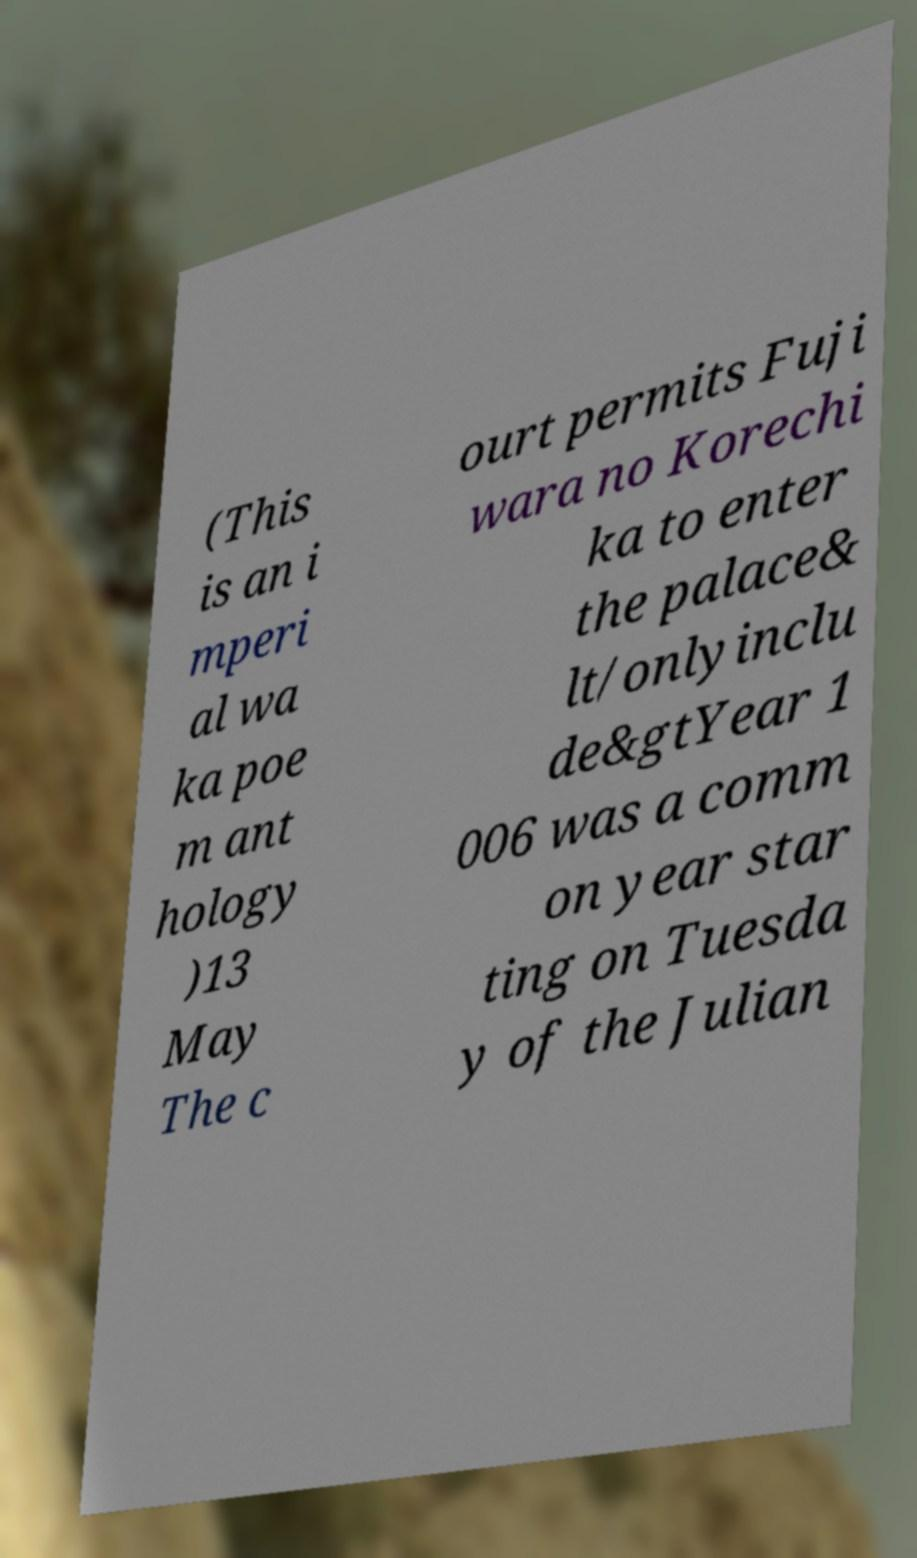Could you extract and type out the text from this image? (This is an i mperi al wa ka poe m ant hology )13 May The c ourt permits Fuji wara no Korechi ka to enter the palace& lt/onlyinclu de&gtYear 1 006 was a comm on year star ting on Tuesda y of the Julian 